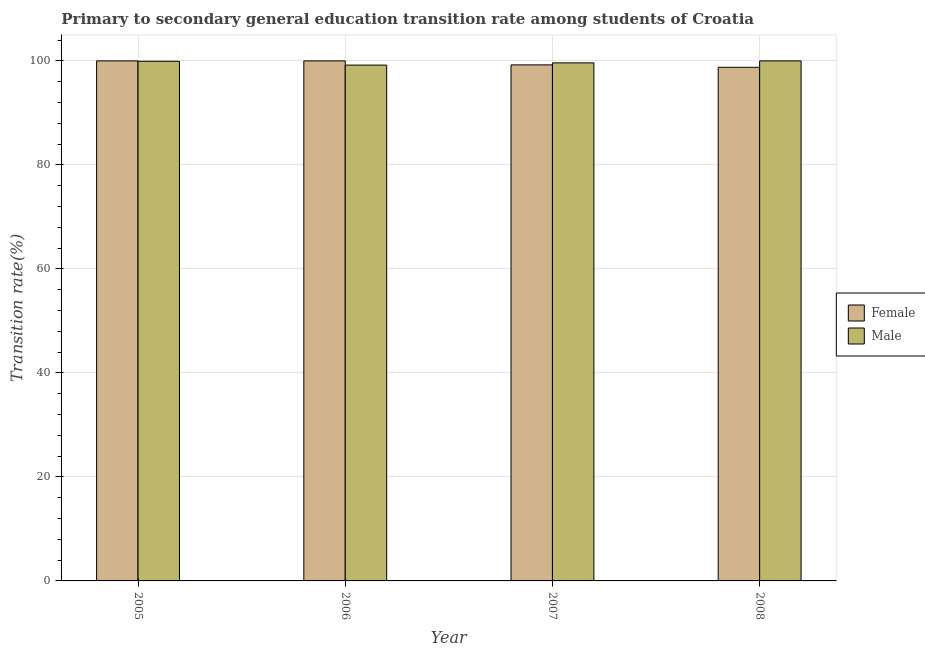Are the number of bars per tick equal to the number of legend labels?
Ensure brevity in your answer.  Yes. Are the number of bars on each tick of the X-axis equal?
Give a very brief answer. Yes. How many bars are there on the 3rd tick from the left?
Provide a short and direct response. 2. How many bars are there on the 1st tick from the right?
Your answer should be compact. 2. What is the transition rate among male students in 2006?
Offer a very short reply. 99.19. Across all years, what is the minimum transition rate among male students?
Offer a terse response. 99.19. In which year was the transition rate among male students maximum?
Make the answer very short. 2008. What is the total transition rate among female students in the graph?
Provide a short and direct response. 397.99. What is the difference between the transition rate among male students in 2005 and that in 2006?
Provide a succinct answer. 0.74. What is the difference between the transition rate among male students in 2005 and the transition rate among female students in 2006?
Provide a short and direct response. 0.74. What is the average transition rate among female students per year?
Provide a short and direct response. 99.5. In how many years, is the transition rate among male students greater than 96 %?
Provide a succinct answer. 4. What is the ratio of the transition rate among male students in 2005 to that in 2006?
Your answer should be compact. 1.01. Is the transition rate among male students in 2007 less than that in 2008?
Make the answer very short. Yes. What is the difference between the highest and the lowest transition rate among female students?
Your answer should be very brief. 1.23. In how many years, is the transition rate among male students greater than the average transition rate among male students taken over all years?
Ensure brevity in your answer.  2. What does the 1st bar from the left in 2006 represents?
Provide a succinct answer. Female. What does the 2nd bar from the right in 2007 represents?
Keep it short and to the point. Female. How many bars are there?
Make the answer very short. 8. Are the values on the major ticks of Y-axis written in scientific E-notation?
Keep it short and to the point. No. Does the graph contain any zero values?
Provide a succinct answer. No. Where does the legend appear in the graph?
Ensure brevity in your answer.  Center right. How many legend labels are there?
Offer a terse response. 2. How are the legend labels stacked?
Provide a short and direct response. Vertical. What is the title of the graph?
Offer a very short reply. Primary to secondary general education transition rate among students of Croatia. Does "RDB concessional" appear as one of the legend labels in the graph?
Your response must be concise. No. What is the label or title of the X-axis?
Give a very brief answer. Year. What is the label or title of the Y-axis?
Give a very brief answer. Transition rate(%). What is the Transition rate(%) of Male in 2005?
Provide a short and direct response. 99.93. What is the Transition rate(%) of Female in 2006?
Offer a terse response. 100. What is the Transition rate(%) in Male in 2006?
Give a very brief answer. 99.19. What is the Transition rate(%) of Female in 2007?
Your answer should be very brief. 99.23. What is the Transition rate(%) in Male in 2007?
Offer a terse response. 99.62. What is the Transition rate(%) of Female in 2008?
Your response must be concise. 98.77. Across all years, what is the maximum Transition rate(%) of Female?
Ensure brevity in your answer.  100. Across all years, what is the maximum Transition rate(%) of Male?
Your answer should be very brief. 100. Across all years, what is the minimum Transition rate(%) in Female?
Offer a terse response. 98.77. Across all years, what is the minimum Transition rate(%) of Male?
Your answer should be very brief. 99.19. What is the total Transition rate(%) in Female in the graph?
Make the answer very short. 397.99. What is the total Transition rate(%) in Male in the graph?
Ensure brevity in your answer.  398.73. What is the difference between the Transition rate(%) of Female in 2005 and that in 2006?
Your answer should be very brief. 0. What is the difference between the Transition rate(%) in Male in 2005 and that in 2006?
Give a very brief answer. 0.74. What is the difference between the Transition rate(%) of Female in 2005 and that in 2007?
Your answer should be very brief. 0.77. What is the difference between the Transition rate(%) of Male in 2005 and that in 2007?
Keep it short and to the point. 0.31. What is the difference between the Transition rate(%) in Female in 2005 and that in 2008?
Make the answer very short. 1.24. What is the difference between the Transition rate(%) of Male in 2005 and that in 2008?
Offer a very short reply. -0.07. What is the difference between the Transition rate(%) of Female in 2006 and that in 2007?
Ensure brevity in your answer.  0.77. What is the difference between the Transition rate(%) of Male in 2006 and that in 2007?
Provide a succinct answer. -0.43. What is the difference between the Transition rate(%) of Female in 2006 and that in 2008?
Keep it short and to the point. 1.24. What is the difference between the Transition rate(%) in Male in 2006 and that in 2008?
Your answer should be very brief. -0.81. What is the difference between the Transition rate(%) of Female in 2007 and that in 2008?
Offer a terse response. 0.46. What is the difference between the Transition rate(%) in Male in 2007 and that in 2008?
Provide a short and direct response. -0.38. What is the difference between the Transition rate(%) of Female in 2005 and the Transition rate(%) of Male in 2006?
Keep it short and to the point. 0.81. What is the difference between the Transition rate(%) in Female in 2005 and the Transition rate(%) in Male in 2007?
Keep it short and to the point. 0.38. What is the difference between the Transition rate(%) of Female in 2005 and the Transition rate(%) of Male in 2008?
Ensure brevity in your answer.  0. What is the difference between the Transition rate(%) of Female in 2006 and the Transition rate(%) of Male in 2007?
Give a very brief answer. 0.38. What is the difference between the Transition rate(%) of Female in 2006 and the Transition rate(%) of Male in 2008?
Ensure brevity in your answer.  0. What is the difference between the Transition rate(%) of Female in 2007 and the Transition rate(%) of Male in 2008?
Provide a short and direct response. -0.77. What is the average Transition rate(%) of Female per year?
Your answer should be very brief. 99.5. What is the average Transition rate(%) of Male per year?
Provide a succinct answer. 99.68. In the year 2005, what is the difference between the Transition rate(%) in Female and Transition rate(%) in Male?
Your answer should be compact. 0.07. In the year 2006, what is the difference between the Transition rate(%) in Female and Transition rate(%) in Male?
Give a very brief answer. 0.81. In the year 2007, what is the difference between the Transition rate(%) in Female and Transition rate(%) in Male?
Provide a succinct answer. -0.39. In the year 2008, what is the difference between the Transition rate(%) of Female and Transition rate(%) of Male?
Provide a succinct answer. -1.24. What is the ratio of the Transition rate(%) in Male in 2005 to that in 2006?
Your response must be concise. 1.01. What is the ratio of the Transition rate(%) in Female in 2005 to that in 2007?
Keep it short and to the point. 1.01. What is the ratio of the Transition rate(%) in Female in 2005 to that in 2008?
Your answer should be very brief. 1.01. What is the ratio of the Transition rate(%) of Female in 2006 to that in 2007?
Give a very brief answer. 1.01. What is the ratio of the Transition rate(%) of Female in 2006 to that in 2008?
Make the answer very short. 1.01. What is the ratio of the Transition rate(%) in Female in 2007 to that in 2008?
Your answer should be compact. 1. What is the difference between the highest and the second highest Transition rate(%) in Male?
Offer a terse response. 0.07. What is the difference between the highest and the lowest Transition rate(%) in Female?
Your answer should be compact. 1.24. What is the difference between the highest and the lowest Transition rate(%) in Male?
Give a very brief answer. 0.81. 